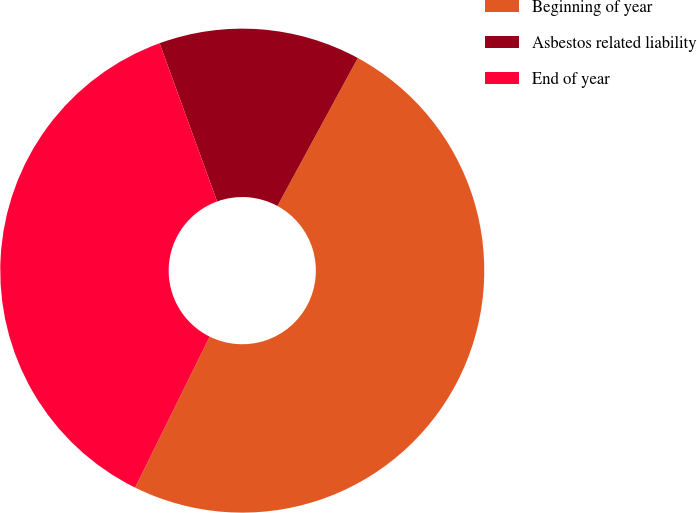Convert chart. <chart><loc_0><loc_0><loc_500><loc_500><pie_chart><fcel>Beginning of year<fcel>Asbestos related liability<fcel>End of year<nl><fcel>49.38%<fcel>13.47%<fcel>37.15%<nl></chart> 